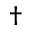<formula> <loc_0><loc_0><loc_500><loc_500>\dagger</formula> 